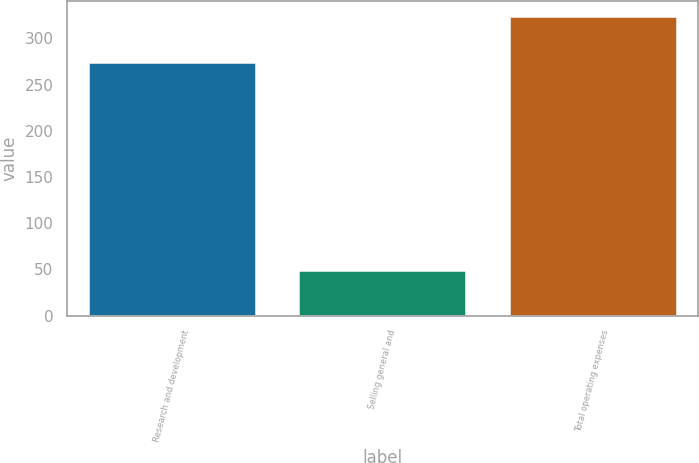Convert chart to OTSL. <chart><loc_0><loc_0><loc_500><loc_500><bar_chart><fcel>Research and development<fcel>Selling general and<fcel>Total operating expenses<nl><fcel>274.9<fcel>48.9<fcel>324.7<nl></chart> 